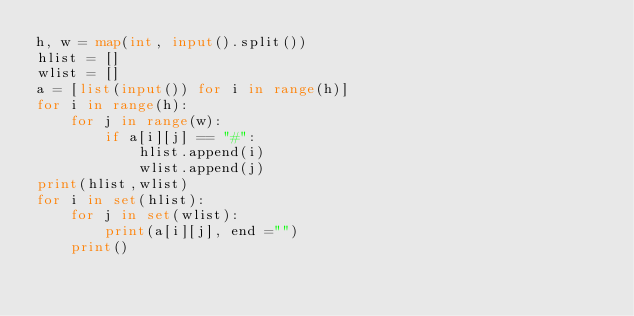Convert code to text. <code><loc_0><loc_0><loc_500><loc_500><_Python_>h, w = map(int, input().split())
hlist = []
wlist = []
a = [list(input()) for i in range(h)]
for i in range(h):
    for j in range(w):
        if a[i][j] == "#":
            hlist.append(i)
            wlist.append(j)
print(hlist,wlist)
for i in set(hlist):
    for j in set(wlist):
        print(a[i][j], end ="")
    print()</code> 